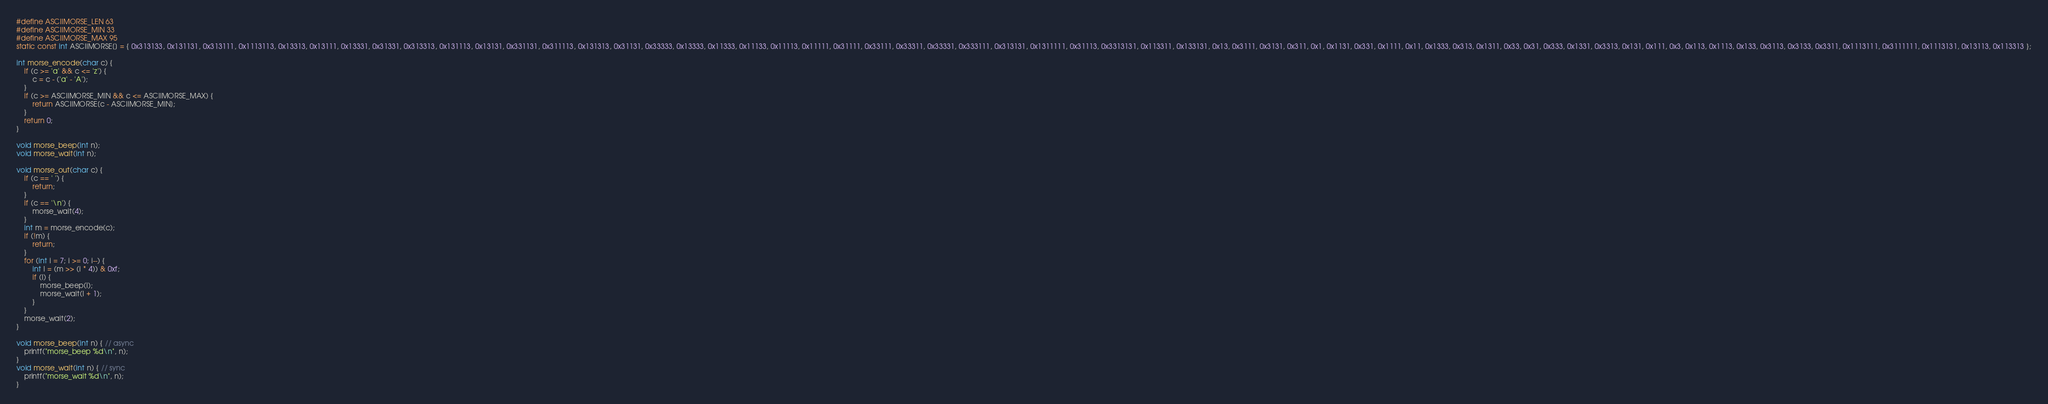Convert code to text. <code><loc_0><loc_0><loc_500><loc_500><_C_>#define ASCIIMORSE_LEN 63
#define ASCIIMORSE_MIN 33
#define ASCIIMORSE_MAX 95
static const int ASCIIMORSE[] = { 0x313133, 0x131131, 0x313111, 0x1113113, 0x13313, 0x13111, 0x13331, 0x31331, 0x313313, 0x131113, 0x13131, 0x331131, 0x311113, 0x131313, 0x31131, 0x33333, 0x13333, 0x11333, 0x11133, 0x11113, 0x11111, 0x31111, 0x33111, 0x33311, 0x33331, 0x333111, 0x313131, 0x1311111, 0x31113, 0x3313131, 0x113311, 0x133131, 0x13, 0x3111, 0x3131, 0x311, 0x1, 0x1131, 0x331, 0x1111, 0x11, 0x1333, 0x313, 0x1311, 0x33, 0x31, 0x333, 0x1331, 0x3313, 0x131, 0x111, 0x3, 0x113, 0x1113, 0x133, 0x3113, 0x3133, 0x3311, 0x1113111, 0x3111111, 0x1113131, 0x13113, 0x113313 };

int morse_encode(char c) {
    if (c >= 'a' && c <= 'z') {
        c = c - ('a' - 'A');
    }
    if (c >= ASCIIMORSE_MIN && c <= ASCIIMORSE_MAX) {
        return ASCIIMORSE[c - ASCIIMORSE_MIN];
    }
    return 0;
}

void morse_beep(int n);
void morse_wait(int n);

void morse_out(char c) {
    if (c == ' ') {
        return;
    }
    if (c == '\n') {
        morse_wait(4);
    }
    int m = morse_encode(c);
    if (!m) {
        return;
    }
    for (int i = 7; i >= 0; i--) {
        int l = (m >> (i * 4)) & 0xf;
        if (l) {
            morse_beep(l);
            morse_wait(l + 1);
        }
    }
    morse_wait(2);
}

void morse_beep(int n) { // async
    printf("morse_beep %d\n", n);
}
void morse_wait(int n) { // sync
    printf("morse_wait %d\n", n);
}
</code> 